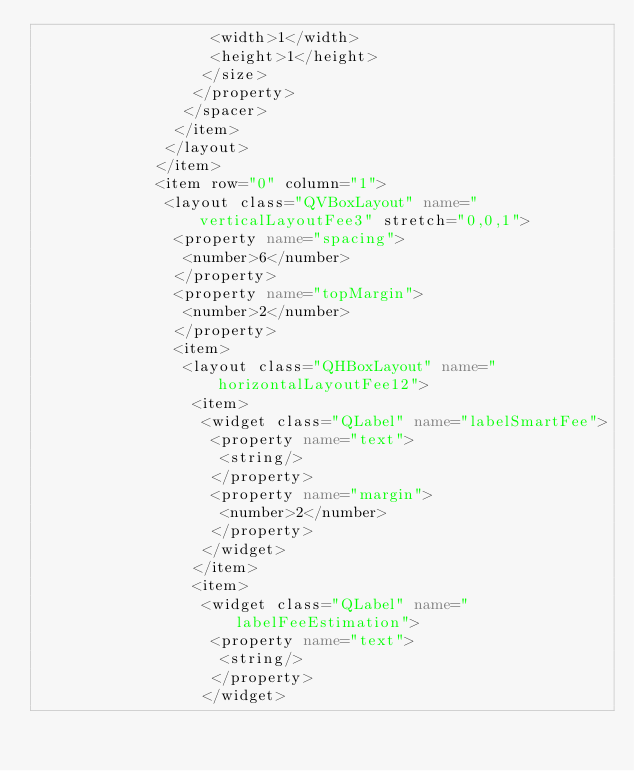Convert code to text. <code><loc_0><loc_0><loc_500><loc_500><_XML_>                   <width>1</width>
                   <height>1</height>
                  </size>
                 </property>
                </spacer>
               </item>
              </layout>
             </item>
             <item row="0" column="1">
              <layout class="QVBoxLayout" name="verticalLayoutFee3" stretch="0,0,1">
               <property name="spacing">
                <number>6</number>
               </property>
               <property name="topMargin">
                <number>2</number>
               </property>
               <item>
                <layout class="QHBoxLayout" name="horizontalLayoutFee12">
                 <item>
                  <widget class="QLabel" name="labelSmartFee">
                   <property name="text">
                    <string/>
                   </property>
                   <property name="margin">
                    <number>2</number>
                   </property>
                  </widget>
                 </item>
                 <item>
                  <widget class="QLabel" name="labelFeeEstimation">
                   <property name="text">
                    <string/>
                   </property>
                  </widget></code> 